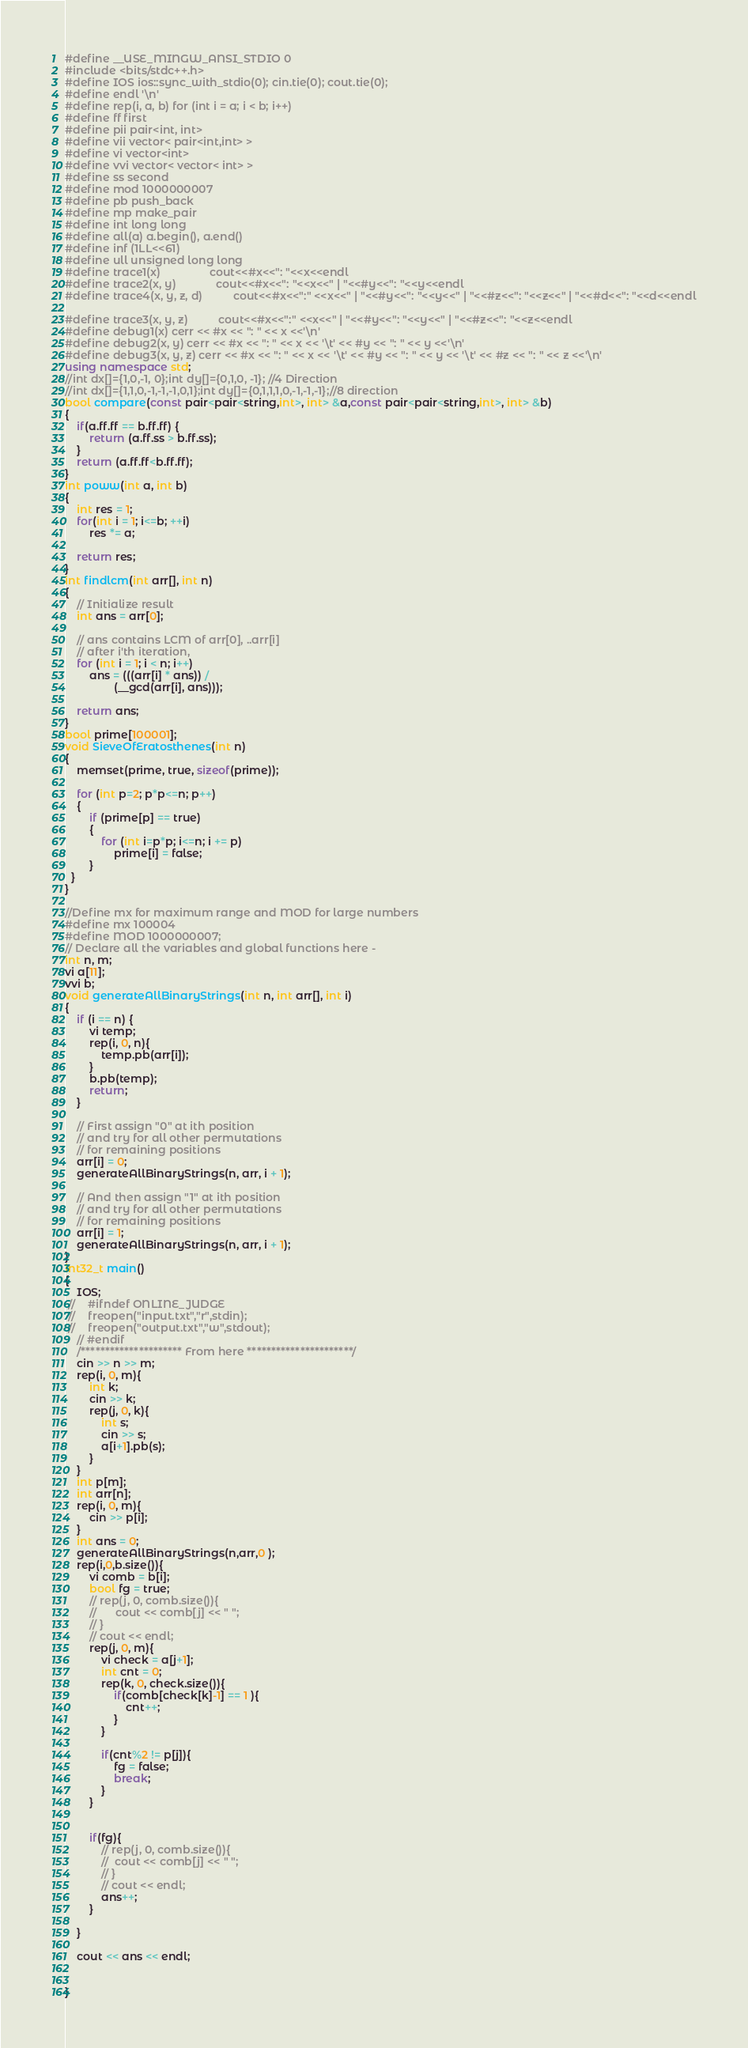<code> <loc_0><loc_0><loc_500><loc_500><_C++_>#define __USE_MINGW_ANSI_STDIO 0
#include <bits/stdc++.h>
#define IOS ios::sync_with_stdio(0); cin.tie(0); cout.tie(0);
#define endl '\n'
#define rep(i, a, b) for (int i = a; i < b; i++)
#define ff first
#define pii pair<int, int>
#define vii vector< pair<int,int> >
#define vi vector<int>
#define vvi vector< vector< int> >
#define ss second
#define mod 1000000007
#define pb push_back
#define mp make_pair
#define int long long
#define all(a) a.begin(), a.end()
#define inf (1LL<<61)
#define ull unsigned long long
#define trace1(x)                cout<<#x<<": "<<x<<endl
#define trace2(x, y)             cout<<#x<<": "<<x<<" | "<<#y<<": "<<y<<endl
#define trace4(x, y, z, d)          cout<<#x<<":" <<x<<" | "<<#y<<": "<<y<<" | "<<#z<<": "<<z<<" | "<<#d<<": "<<d<<endl

#define trace3(x, y, z)          cout<<#x<<":" <<x<<" | "<<#y<<": "<<y<<" | "<<#z<<": "<<z<<endl
#define debug1(x) cerr << #x << ": " << x <<'\n'
#define debug2(x, y) cerr << #x << ": " << x << '\t' << #y << ": " << y <<'\n'
#define debug3(x, y, z) cerr << #x << ": " << x << '\t' << #y << ": " << y << '\t' << #z << ": " << z <<'\n'
using namespace std;
//int dx[]={1,0,-1, 0};int dy[]={0,1,0, -1}; //4 Direction
//int dx[]={1,1,0,-1,-1,-1,0,1};int dy[]={0,1,1,1,0,-1,-1,-1};//8 direction
bool compare(const pair<pair<string,int>, int> &a,const pair<pair<string,int>, int> &b)
{
    if(a.ff.ff == b.ff.ff) {
        return (a.ff.ss > b.ff.ss);
    }
    return (a.ff.ff<b.ff.ff);
}
int poww(int a, int b)
{
    int res = 1;
    for(int i = 1; i<=b; ++i)
        res *= a;

    return res;
}
int findlcm(int arr[], int n) 
{ 
    // Initialize result 
    int ans = arr[0]; 
  
    // ans contains LCM of arr[0], ..arr[i] 
    // after i'th iteration, 
    for (int i = 1; i < n; i++) 
        ans = (((arr[i] * ans)) / 
                (__gcd(arr[i], ans))); 
  
    return ans; 
}
bool prime[100001];
void SieveOfEratosthenes(int n) 
{
    memset(prime, true, sizeof(prime));

    for (int p=2; p*p<=n; p++)
    {
        if (prime[p] == true)
        {
            for (int i=p*p; i<=n; i += p)
                prime[i] = false;
        }
  }
}

//Define mx for maximum range and MOD for large numbers
#define mx 100004
#define MOD 1000000007;
// Declare all the variables and global functions here - 
int n, m;
vi a[11];
vvi b;
void generateAllBinaryStrings(int n, int arr[], int i) 
{ 
    if (i == n) { 
    	vi temp;
    	rep(i, 0, n){
    		temp.pb(arr[i]);
    	}
    	b.pb(temp);
        return; 
    } 
  
    // First assign "0" at ith position 
    // and try for all other permutations 
    // for remaining positions 
    arr[i] = 0; 
    generateAllBinaryStrings(n, arr, i + 1); 
  
    // And then assign "1" at ith position 
    // and try for all other permutations 
    // for remaining positions 
    arr[i] = 1; 
    generateAllBinaryStrings(n, arr, i + 1); 
}
int32_t main()
{
    IOS;
 //    #ifndef ONLINE_JUDGE
 //    freopen("input.txt","r",stdin);
 //    freopen("output.txt","w",stdout);
	// #endif
    /********************* From here **********************/
    cin >> n >> m;
    rep(i, 0, m){
    	int k;
    	cin >> k;
    	rep(j, 0, k){
    		int s;
    		cin >> s;
    		a[i+1].pb(s);
    	}
    }
    int p[m];
    int arr[n];
    rep(i, 0, m){
    	cin >> p[i];
    }
    int ans = 0;
    generateAllBinaryStrings(n,arr,0 );
    rep(i,0,b.size()){
    	vi comb = b[i];
    	bool fg = true;
    	// rep(j, 0, comb.size()){
    	// 		cout << comb[j] << " ";
    	// }
    	// cout << endl;
    	rep(j, 0, m){
    		vi check = a[j+1];
    		int cnt = 0;
    		rep(k, 0, check.size()){
    			if(comb[check[k]-1] == 1 ){
    				cnt++;
    			}
    		}

    		if(cnt%2 != p[j]){
    			fg = false;
    			break;
    		}
    	}

    	
    	if(fg){
    		// rep(j, 0, comb.size()){
    		// 	cout << comb[j] << " ";
    		// }
    		// cout << endl;
    		ans++;
    	}
    	
    }

    cout << ans << endl;
    
    
}</code> 